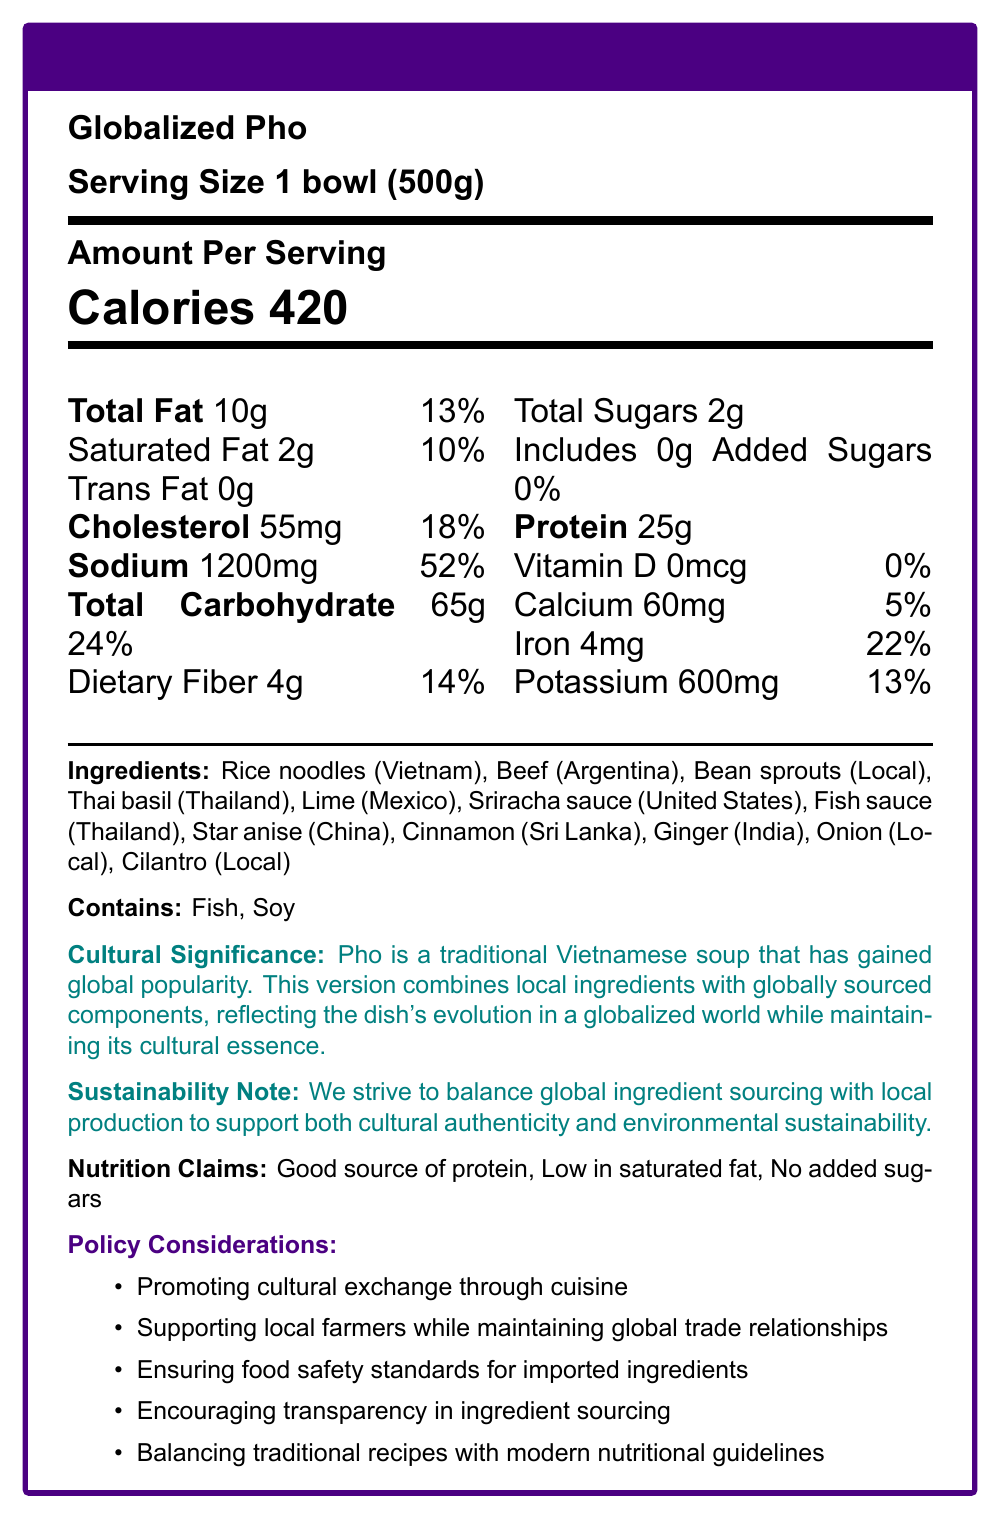what is the serving size? The serving size indicated in the document is "1 bowl (500g)".
Answer: 1 bowl (500g) How many calories are in a serving of Globalized Pho? The document states that each serving of Globalized Pho contains 420 calories.
Answer: 420 Which ingredient is sourced from Vietnam? According to the ingredients list, the rice noodles are sourced from Vietnam.
Answer: Rice noodles What is the percentage daily value of sodium in Globalized Pho? The document shows that a serving of Globalized Pho provides 52% of the daily value for sodium.
Answer: 52% What allergens are present in Globalized Pho? The document lists fish and soy as the allergens contained in the dish.
Answer: Fish, Soy Which country provides the beef for Globalized Pho? The ingredients list states that the beef is sourced from Argentina.
Answer: Argentina What nutritional claims are made about Globalized Pho? A. High in calories B. Low in saturated fat C. Contains added sugars The nutrition claims listed include: "Good source of protein," "Low in saturated fat," and "No added sugars."
Answer: B. Low in saturated fat Which policy consideration focuses on local farmers? A. Promoting cultural exchange B. Supporting local farmers while maintaining global trade relationships C. Ensuring food safety standards The policy consideration "Supporting local farmers while maintaining global trade relationships" focuses on local farmers.
Answer: B. Supporting local farmers while maintaining global trade relationships Is the Globalized Pho high in dietary fiber? The dietary fiber content is 4g, which is only 14% of the daily value, so it is not considered high in dietary fiber.
Answer: No Summarize the main idea of the document. The summary encapsulates all sections of the document, describing the nutritional content, the international sourcing of ingredients, and policy aspects related to cultural preservation and globalization.
Answer: The document provides nutritional information, ingredients, allergens, cultural significance, sustainability notes, and policy considerations for "Globalized Pho," a traditional Vietnamese dish with globally sourced ingredients. How much Vitamin D is present in a serving of Globalized Pho? The document shows that there is no Vitamin D (0mcg) present in a serving of Globalized Pho.
Answer: 0mcg What is the total carbohydrate content in Globalized Pho? The total carbohydrate content per serving is listed as 65 grams.
Answer: 65g What is the purpose of the sustainability note in the document? The sustainability note aims to convey the effort to maintain cultural authenticity and environmental sustainability through a balance of global and local ingredient sourcing.
Answer: To highlight the balance between global ingredient sourcing and local production for cultural authenticity and environmental sustainability. Why is the dish named "Globalized Pho"? The document does not explicitly state why the dish is named "Globalized Pho," though it implies the global sourcing of ingredients gives the dish a global context.
Answer: Not enough information How does the document address balancing traditional recipes with modern nutritional guidelines? The document includes "Balancing traditional recipes with modern nutritional guidelines" as one of the policy considerations.
Answer: It is listed as one of the policy considerations. 